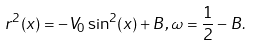<formula> <loc_0><loc_0><loc_500><loc_500>r ^ { 2 } ( x ) = - V _ { 0 } \sin ^ { 2 } ( x ) + B , \omega = \frac { 1 } { 2 } - B .</formula> 